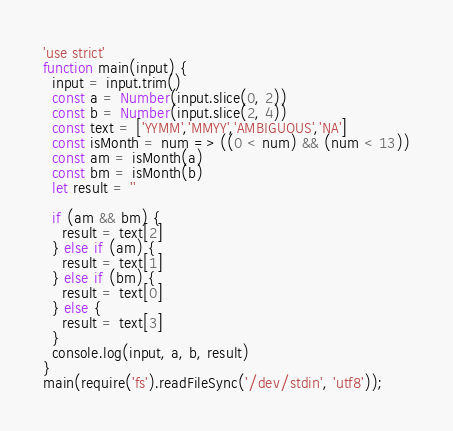<code> <loc_0><loc_0><loc_500><loc_500><_JavaScript_>'use strict'
function main(input) {
  input = input.trim()
  const a = Number(input.slice(0, 2))
  const b = Number(input.slice(2, 4))
  const text = ['YYMM','MMYY','AMBIGUOUS','NA']
  const isMonth = num => ((0 < num) && (num < 13))
  const am = isMonth(a)
  const bm = isMonth(b)
  let result = ''

  if (am && bm) {
    result = text[2]
  } else if (am) {
    result = text[1]
  } else if (bm) {
    result = text[0]
  } else {
    result = text[3]
  }
  console.log(input, a, b, result)
}
main(require('fs').readFileSync('/dev/stdin', 'utf8'));
</code> 